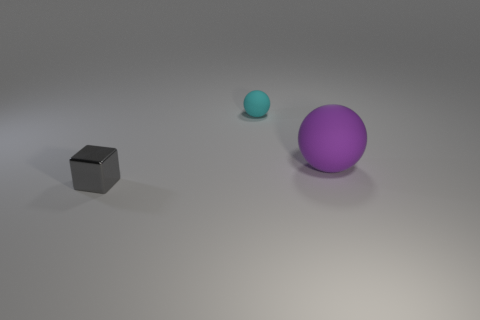What's the relative size of the balls compared to the cube? The purple ball is the largest object, noticeably bigger than the cube and the cyan ball. The cyan ball is smaller than the other two objects, and while we can't measure them exactly, the cube appears to be approximately in a middle ground in terms of size between the cyan ball and the purple ball. 